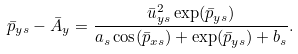<formula> <loc_0><loc_0><loc_500><loc_500>\bar { p } _ { y s } - \bar { A } _ { y } = \frac { \bar { u } _ { y s } ^ { 2 } \exp ( \bar { p } _ { y s } ) } { a _ { s } \cos ( \bar { p } _ { x s } ) + \exp ( \bar { p } _ { y s } ) + b _ { s } } .</formula> 